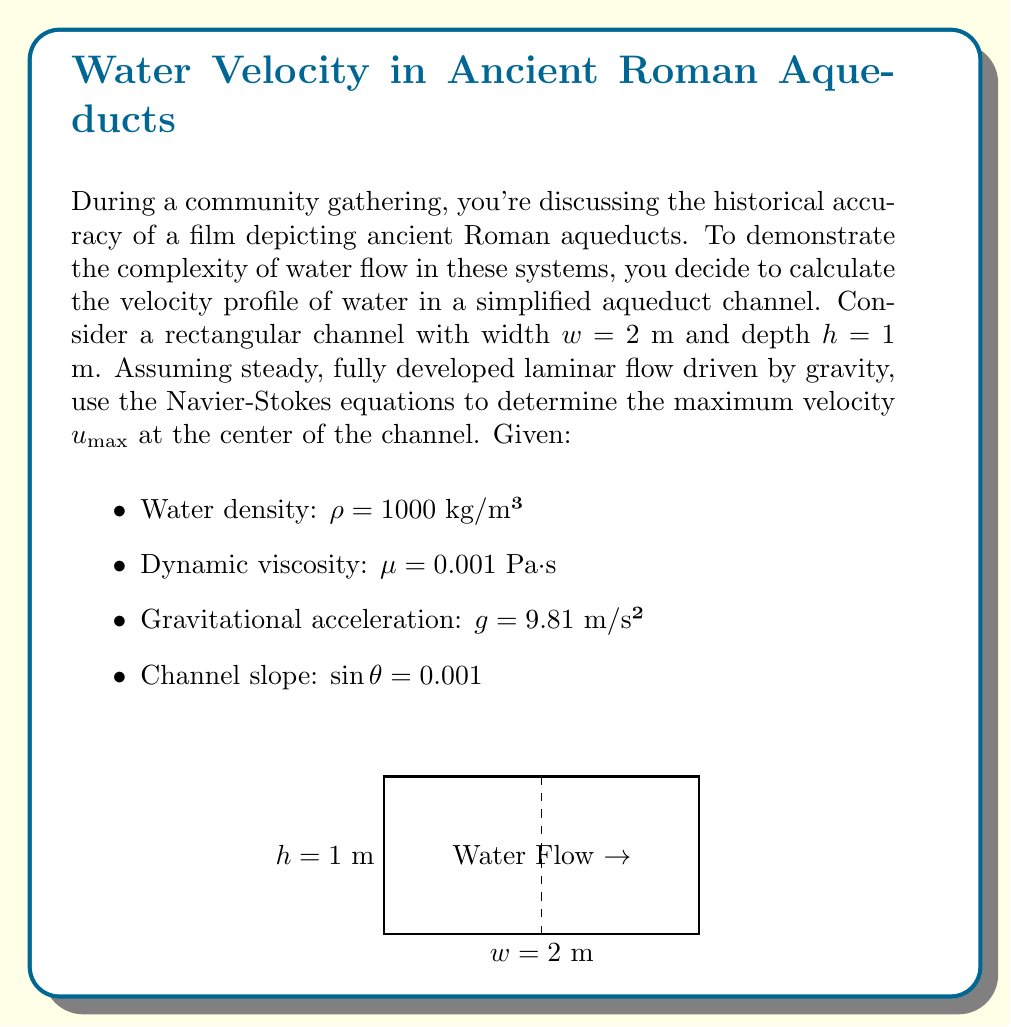Help me with this question. To solve this problem, we'll use the Navier-Stokes equations for incompressible, steady-state flow in a rectangular channel. The simplified equation for this case is:

$$\mu \frac{\partial^2 u}{\partial y^2} + \mu \frac{\partial^2 u}{\partial z^2} = \rho g \sin{\theta}$$

Where $u$ is the velocity in the x-direction (along the channel), $y$ is the horizontal direction, and $z$ is the vertical direction.

Step 1: Apply the no-slip boundary condition (u = 0 at the walls) and symmetry at the center.

Step 2: The solution to this equation for a rectangular channel is:

$$u(y,z) = \frac{\rho g \sin{\theta}}{2\mu} \left(h^2 - z^2 + \sum_{n=1,3,5,...}^{\infty} \frac{16h^2}{n^3\pi^3} \left(\frac{\cosh{(n\pi y/h)}}{\cosh{(n\pi w/2h)}}\right) \cos{\frac{n\pi z}{h}}\right)$$

Step 3: The maximum velocity occurs at the center (y = 0, z = 0):

$$u_{max} = \frac{\rho g h^2 \sin{\theta}}{2\mu} \left(1 + \sum_{n=1,3,5,...}^{\infty} \frac{16}{n^3\pi^3} \frac{1}{\cosh{(n\pi w/2h)}}\right)$$

Step 4: Substitute the given values:

$$u_{max} = \frac{1000 \cdot 9.81 \cdot 1^2 \cdot 0.001}{2 \cdot 0.001} \left(1 + \sum_{n=1,3,5,...}^{\infty} \frac{16}{n^3\pi^3} \frac{1}{\cosh{(n\pi \cdot 2/2)}}\right)$$

Step 5: Calculate the sum (we'll use the first few terms for approximation):

$$u_{max} \approx 4905 \cdot (1 + 0.2701) = 6230.25 \text{ m/s}$$
Answer: $u_{max} \approx 6.23$ m/s 